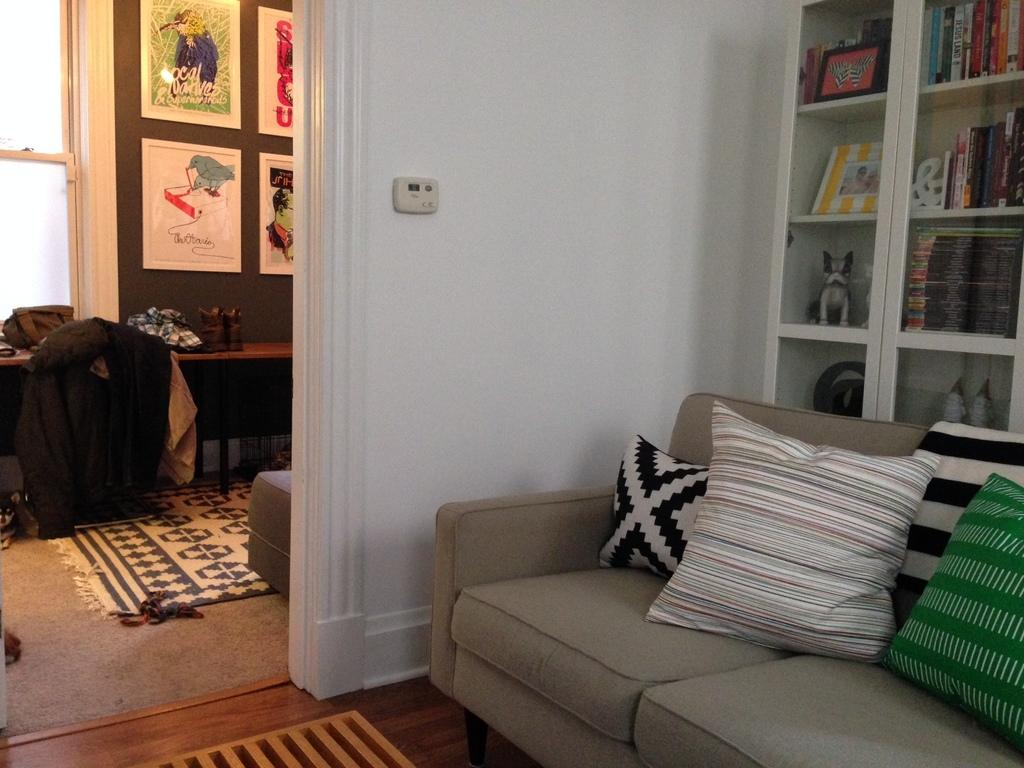What type of furniture is present in the image? There is a sofa with pillows in the image. What other piece of furniture can be seen in the image? There is a cupboard in the image. What type of floor covering is visible in the image? There is a carpet in the image. What is on the table in the image? There are items on a table in the image. What type of decorations are on the wall in the image? There are photo frames on the wall in the image. What type of truck is parked in front of the sofa in the image? There is no truck present in the image; it only features a sofa, cupboard, carpet, items on a table, and photo frames on the wall. 